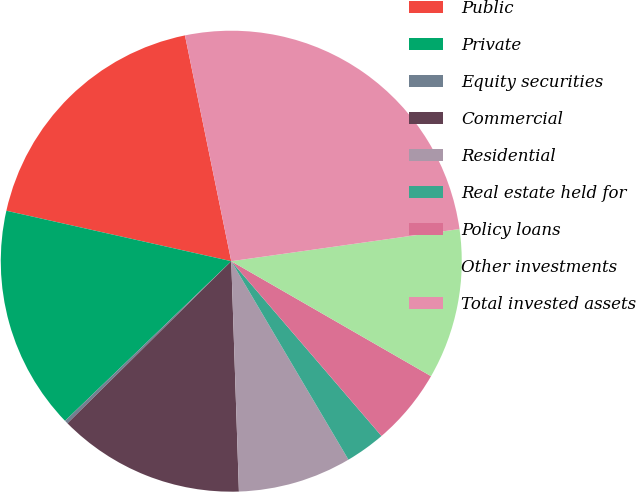Convert chart. <chart><loc_0><loc_0><loc_500><loc_500><pie_chart><fcel>Public<fcel>Private<fcel>Equity securities<fcel>Commercial<fcel>Residential<fcel>Real estate held for<fcel>Policy loans<fcel>Other investments<fcel>Total invested assets<nl><fcel>18.27%<fcel>15.69%<fcel>0.24%<fcel>13.11%<fcel>7.96%<fcel>2.81%<fcel>5.39%<fcel>10.54%<fcel>25.99%<nl></chart> 